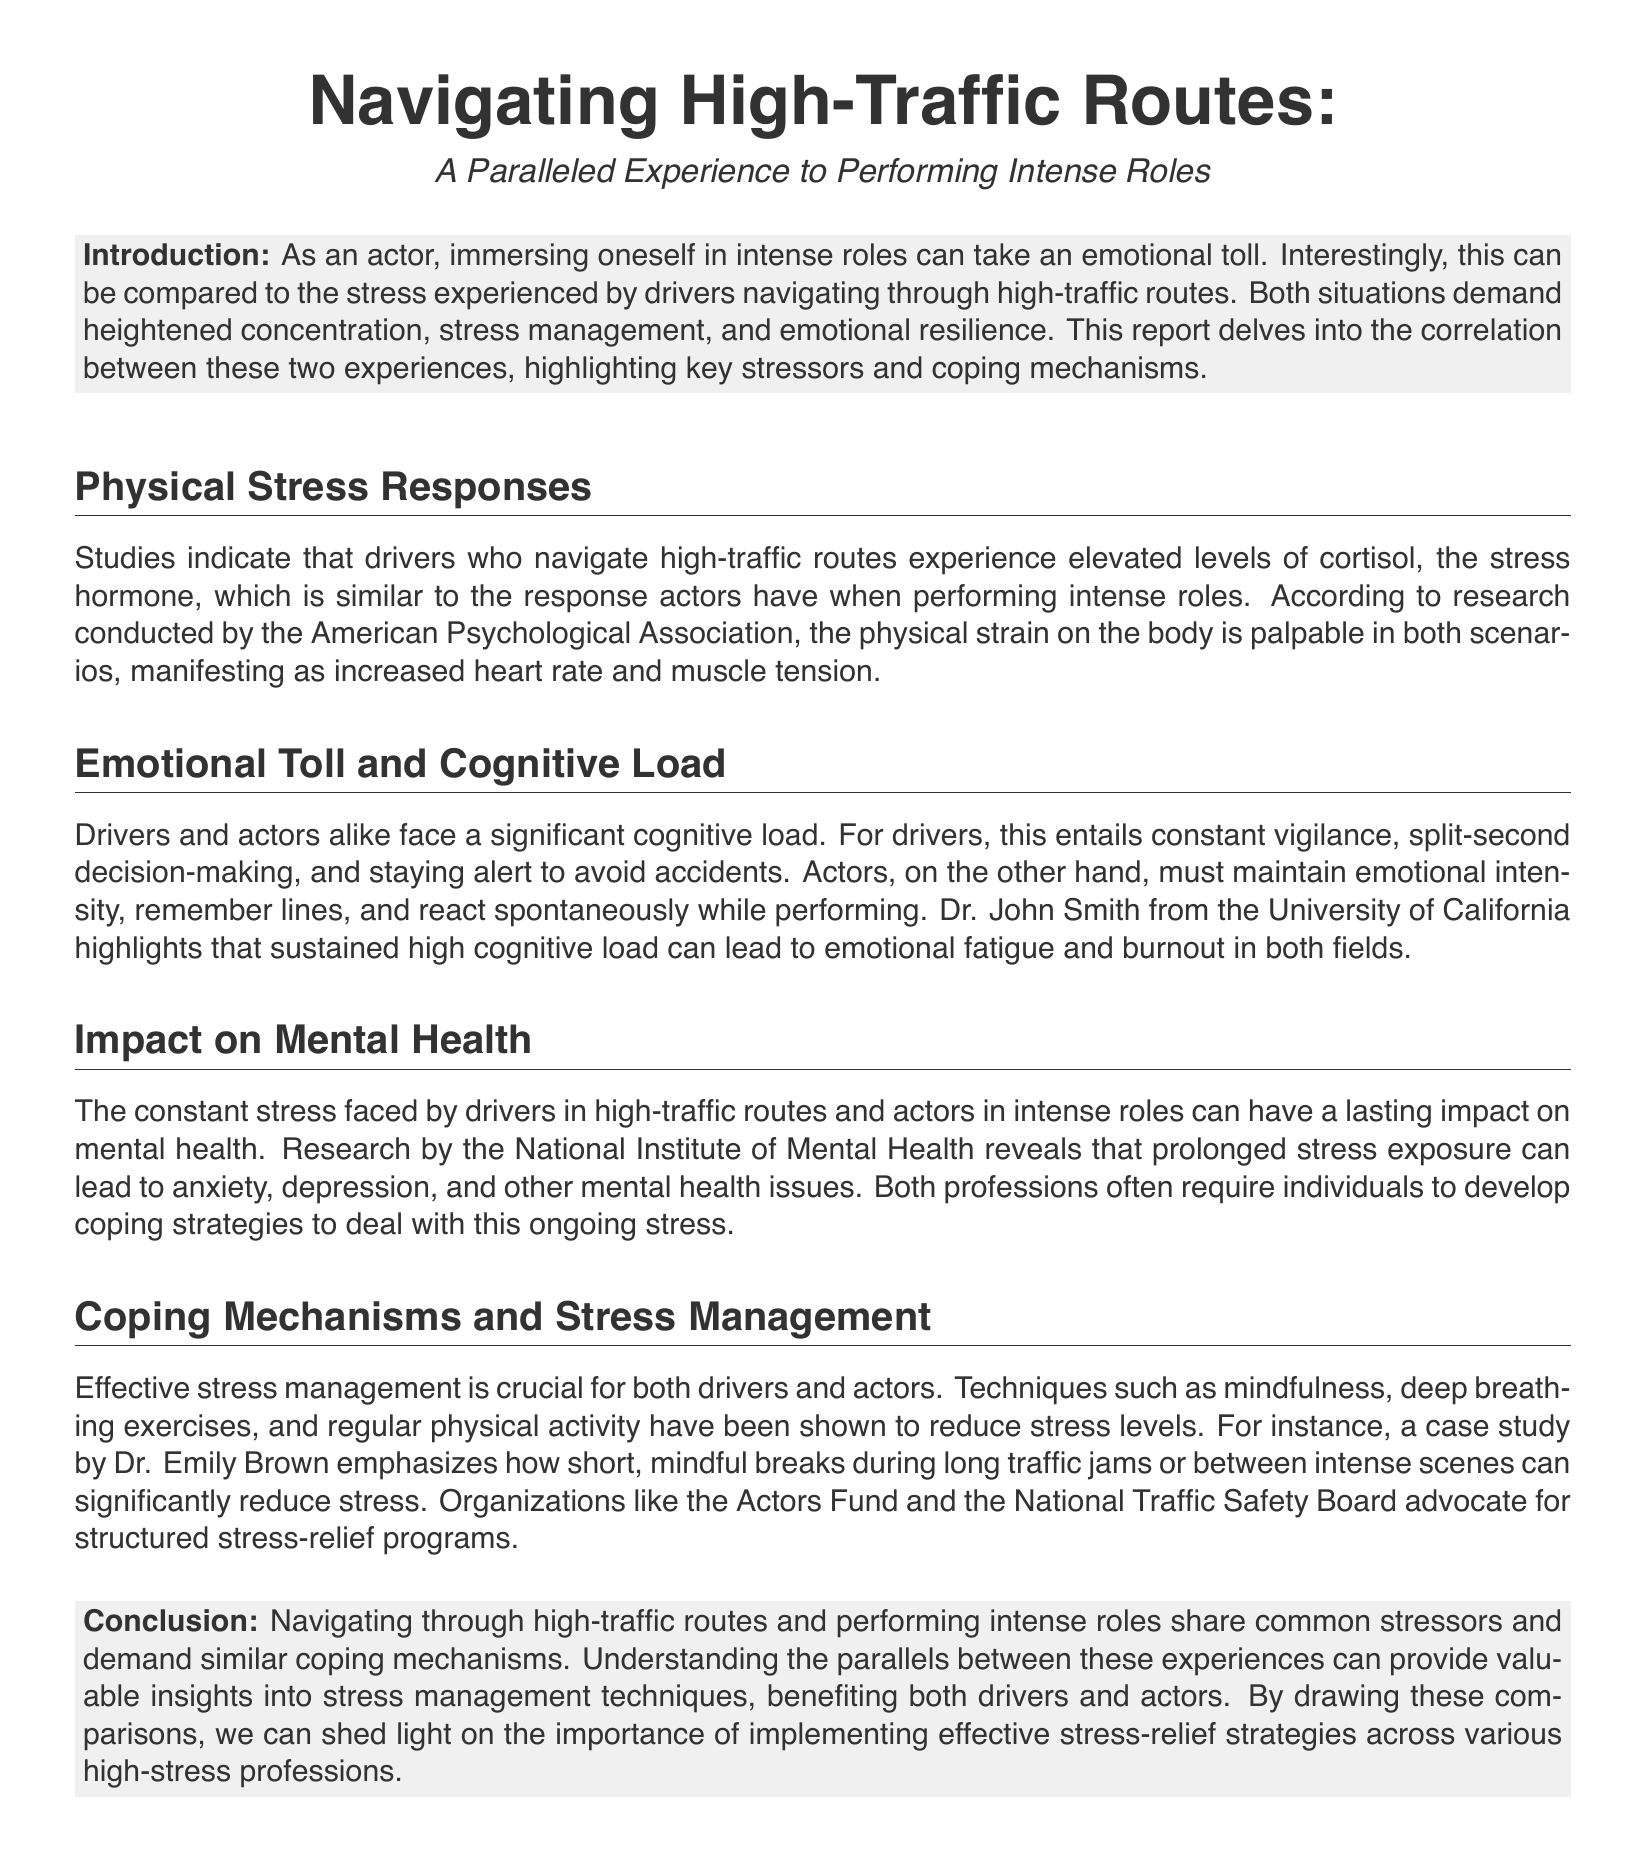What is the stress hormone mentioned? The document states that cortisol is the stress hormone experienced by both drivers and actors.
Answer: cortisol Who conducted research on physical stress responses? The research mentioned is conducted by the American Psychological Association.
Answer: American Psychological Association What is the emotional impact on drivers and actors? The document mentions that prolonged stress exposure can lead to anxiety, depression, and other mental health issues.
Answer: anxiety, depression What coping techniques are suggested in the report? The document lists mindfulness, deep breathing exercises, and regular physical activity as effective stress management techniques.
Answer: mindfulness, deep breathing, activity Which organization advocates for stress-relief programs? The Actors Fund is mentioned as an organization that advocates for structured stress-relief programs.
Answer: Actors Fund What type of load do drivers and actors face? The document refers to a significant cognitive load faced by both drivers and actors.
Answer: cognitive load Who highlighted the impact of sustained high cognitive load? Dr. John Smith from the University of California is mentioned as highlighting this issue.
Answer: Dr. John Smith What is the common goal of both drivers and actors in high-stress situations? The document implies that both must manage stress effectively to perform successfully.
Answer: manage stress 